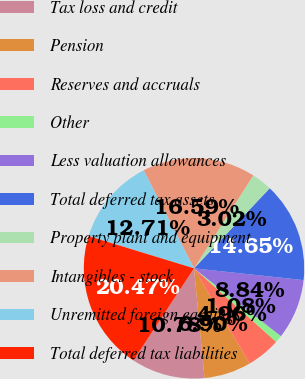Convert chart. <chart><loc_0><loc_0><loc_500><loc_500><pie_chart><fcel>Tax loss and credit<fcel>Pension<fcel>Reserves and accruals<fcel>Other<fcel>Less valuation allowances<fcel>Total deferred tax assets<fcel>Property plant and equipment<fcel>Intangibles - stock<fcel>Unremitted foreign earnings<fcel>Total deferred tax liabilities<nl><fcel>10.78%<fcel>6.9%<fcel>4.96%<fcel>1.08%<fcel>8.84%<fcel>14.65%<fcel>3.02%<fcel>16.59%<fcel>12.71%<fcel>20.47%<nl></chart> 